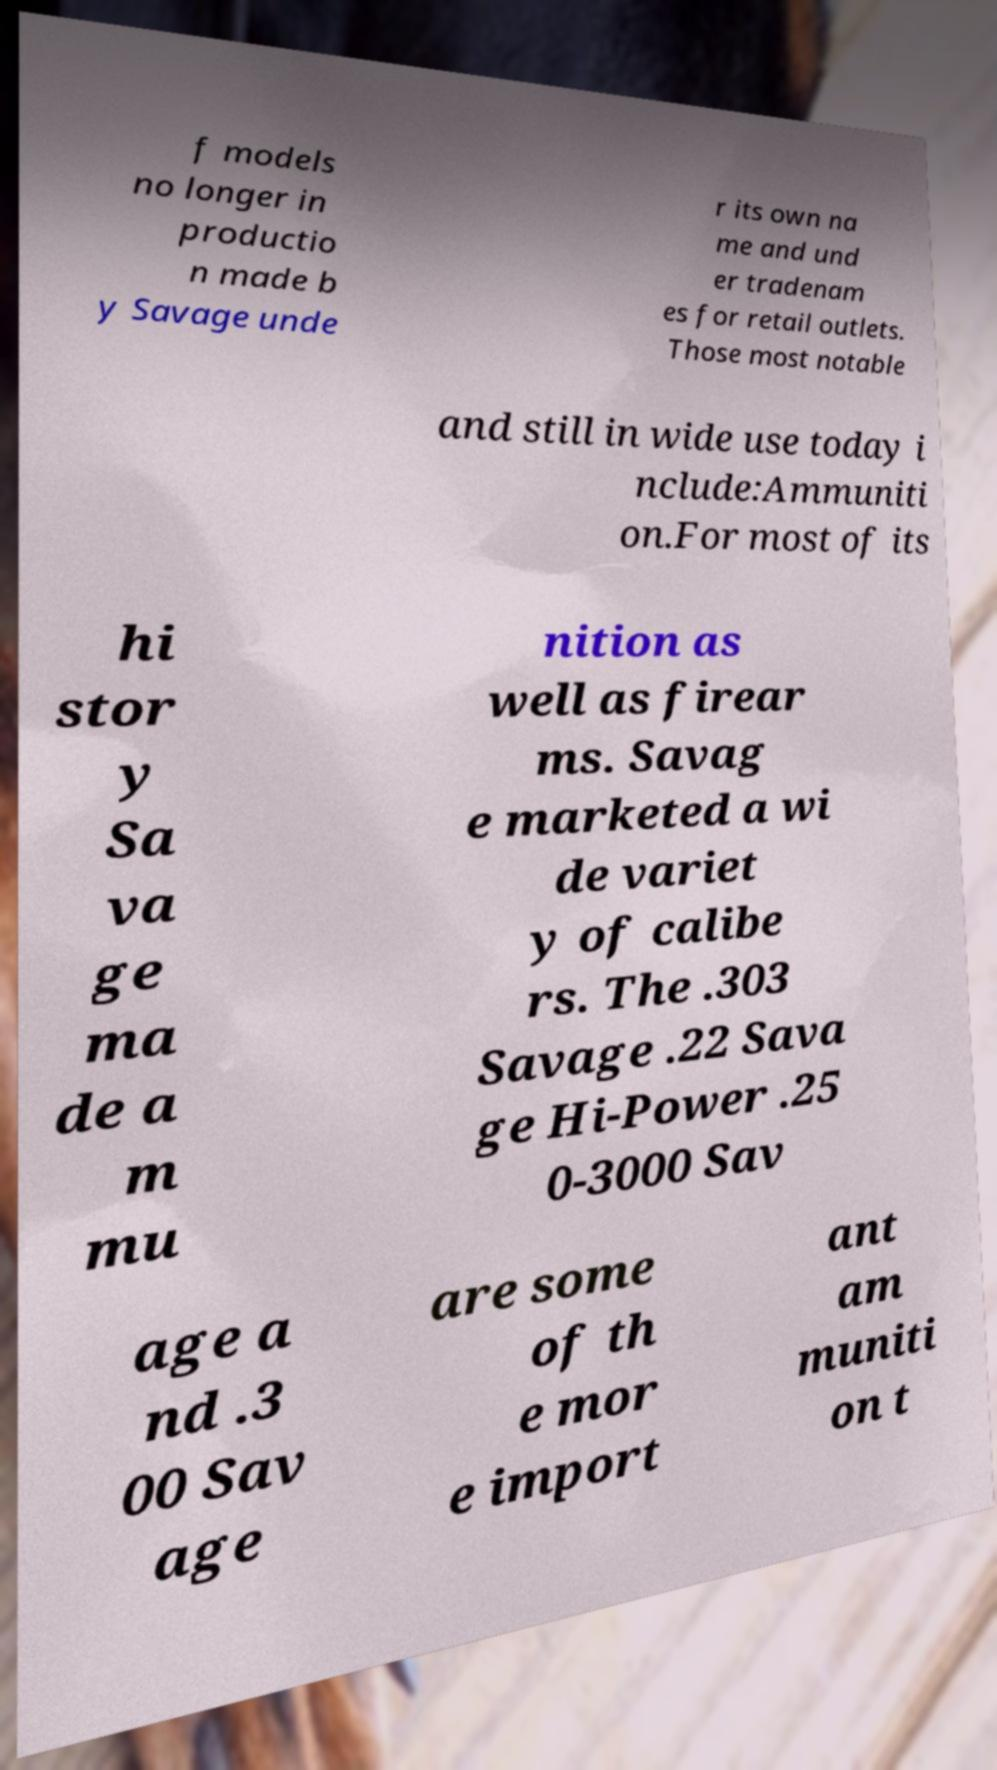For documentation purposes, I need the text within this image transcribed. Could you provide that? f models no longer in productio n made b y Savage unde r its own na me and und er tradenam es for retail outlets. Those most notable and still in wide use today i nclude:Ammuniti on.For most of its hi stor y Sa va ge ma de a m mu nition as well as firear ms. Savag e marketed a wi de variet y of calibe rs. The .303 Savage .22 Sava ge Hi-Power .25 0-3000 Sav age a nd .3 00 Sav age are some of th e mor e import ant am muniti on t 